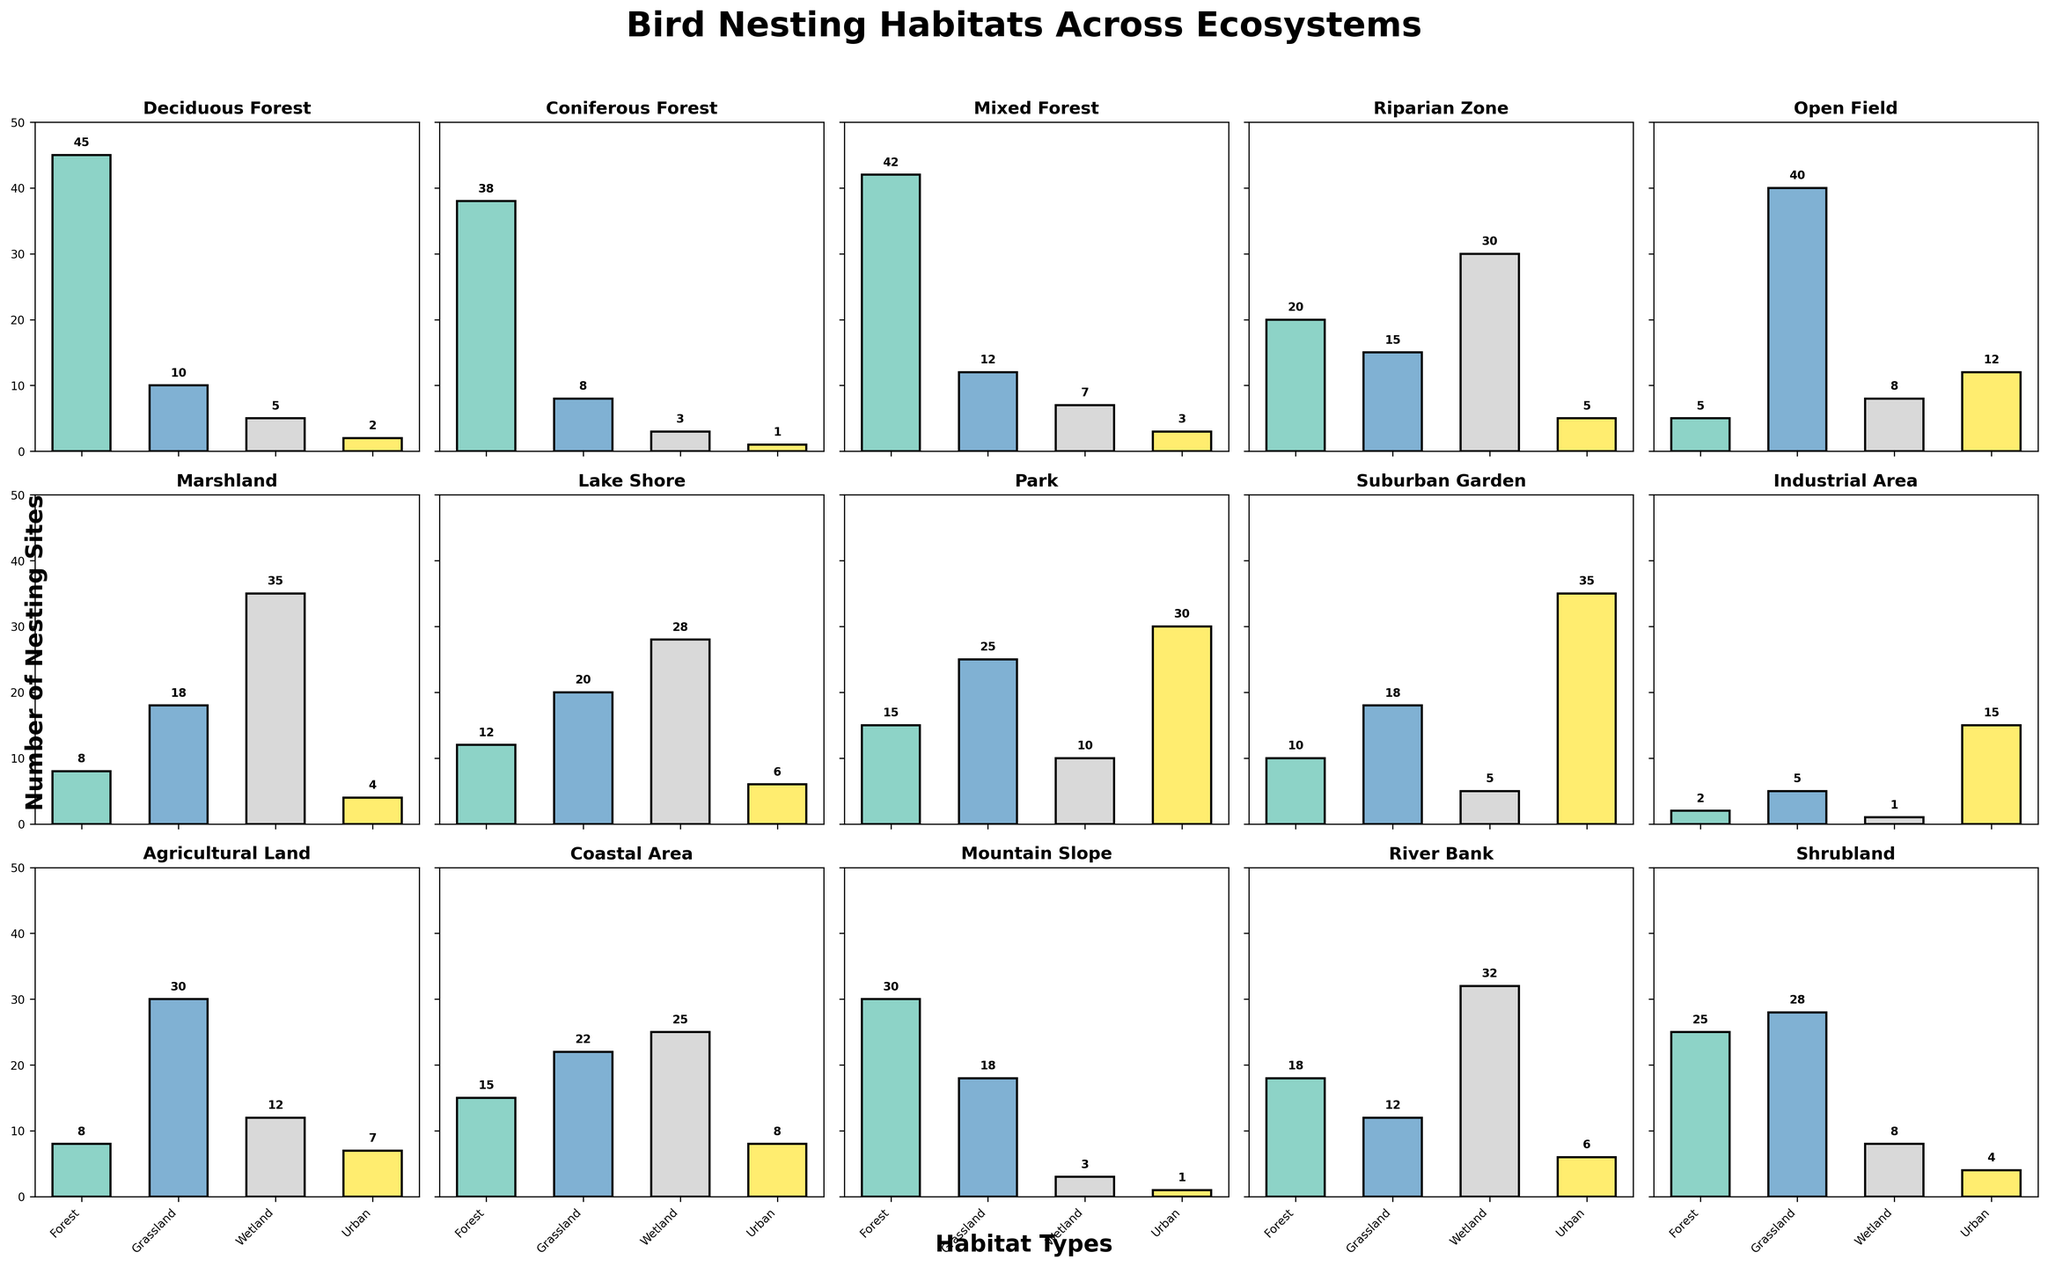Which ecosystem has the most bird nesting sites in Forest habitats? The bar for Forest habitats in Deciduous Forest is the tallest among all ecosystems for the Forest category. It reaches up to 45.
Answer: Deciduous Forest Which ecosystem has the least bird nesting sites in Urban habitats? The bar for Urban habitats in Coniferous Forest is the shortest among all ecosystems for the Urban category. It reaches up to 1.
Answer: Coniferous Forest What is the total number of bird nesting sites in Wetland habitats for Lake Shore and River Bank combined? Lake Shore has 28 Wetland nests and River Bank has 32 Wetland nests. Sum these values: 28 + 32.
Answer: 60 Which habitat type has the least number of bird nesting sites in Park? The bars in Park for Forest, Grassland, Wetland, and Urban habitats are 15, 25, 10, and 30 respectively. The smallest value is 10 for Wetland.
Answer: Wetland How many more bird nesting sites are there in Grassland habitats in Open Field compared to Riparian Zone? Open Field has 40 Grassland nests and Riparian Zone has 15 Grassland nests. Subtract the lesser number from the greater: 40 - 15.
Answer: 25 In which ecosystems do Urban habitats have the highest number of bird nesting sites? The highest Urban habitat bar is found in the Suburban Garden with a value of 35.
Answer: Suburban Garden What is the average number of bird nesting sites in Forest habitats across Deciduous Forest, Coniferous Forest, and Mixed Forest? Add the Forest values for these ecosystems (45 + 38 + 42) and divide by the number of ecosystems (3). Calculation: (45 + 38 + 42) / 3 = 125 / 3.
Answer: 41.67 Which ecosystem has an equal number of bird nesting sites in Grassland and Wetland habitats? In Coastal Area, the bars for Grassland and Wetland are both 25.
Answer: Coastal Area 